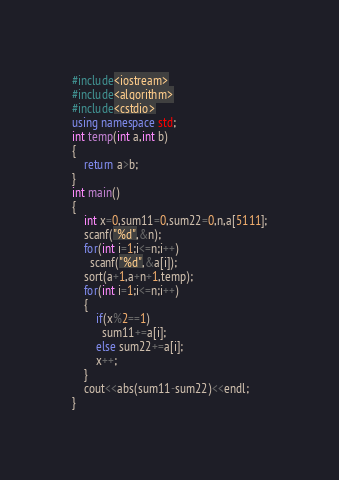<code> <loc_0><loc_0><loc_500><loc_500><_C++_>#include<iostream>
#include<algorithm>
#include<cstdio>
using namespace std;
int temp(int a,int b)
{
	return a>b;
}
int main()
{
	int x=0,sum11=0,sum22=0,n,a[5111];
	scanf("%d",&n);
	for(int i=1;i<=n;i++)
	  scanf("%d",&a[i]);
	sort(a+1,a+n+1,temp);
	for(int i=1;i<=n;i++)
	{
		if(x%2==1)
		  sum11+=a[i];
		else sum22+=a[i];
		x++;
	}
	cout<<abs(sum11-sum22)<<endl;
}</code> 